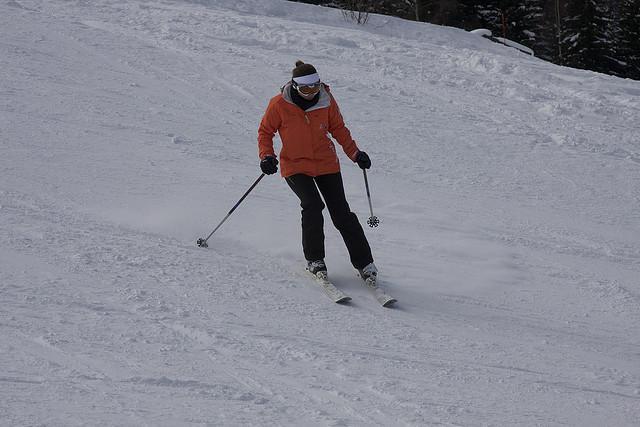How many people are shown?
Give a very brief answer. 1. 